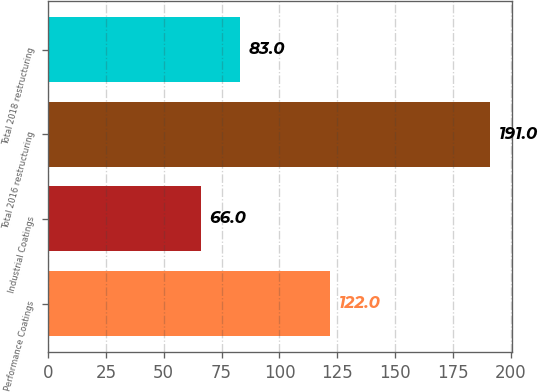Convert chart. <chart><loc_0><loc_0><loc_500><loc_500><bar_chart><fcel>Performance Coatings<fcel>Industrial Coatings<fcel>Total 2016 restructuring<fcel>Total 2018 restructuring<nl><fcel>122<fcel>66<fcel>191<fcel>83<nl></chart> 